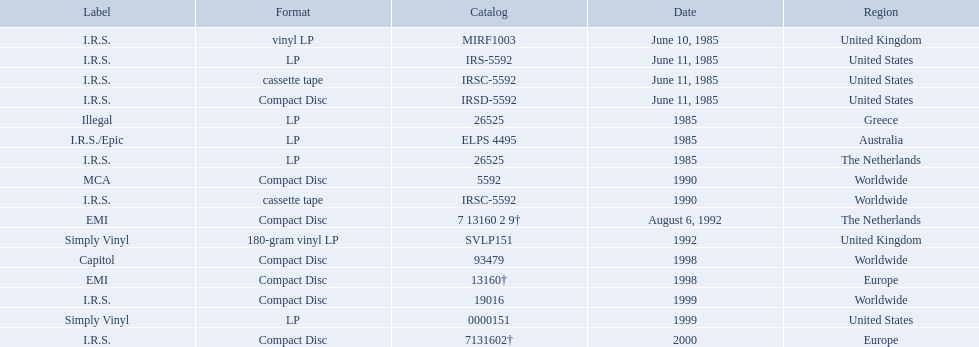Which dates were their releases by fables of the reconstruction? June 10, 1985, June 11, 1985, June 11, 1985, June 11, 1985, 1985, 1985, 1985, 1990, 1990, August 6, 1992, 1992, 1998, 1998, 1999, 1999, 2000. Which of these are in 1985? June 10, 1985, June 11, 1985, June 11, 1985, June 11, 1985, 1985, 1985, 1985. What regions were there releases on these dates? United Kingdom, United States, United States, United States, Greece, Australia, The Netherlands. Which of these are not greece? United Kingdom, United States, United States, United States, Australia, The Netherlands. Which of these regions have two labels listed? Australia. 